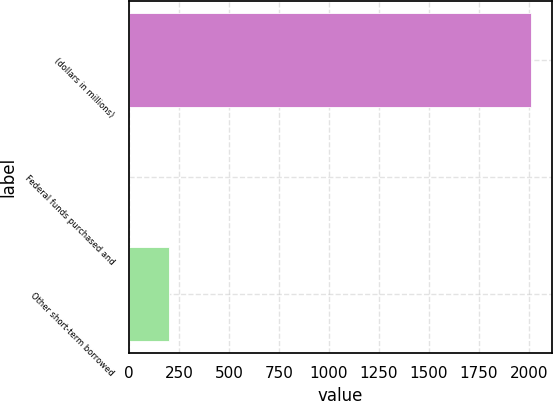<chart> <loc_0><loc_0><loc_500><loc_500><bar_chart><fcel>(dollars in millions)<fcel>Federal funds purchased and<fcel>Other short-term borrowed<nl><fcel>2012<fcel>0.1<fcel>201.29<nl></chart> 